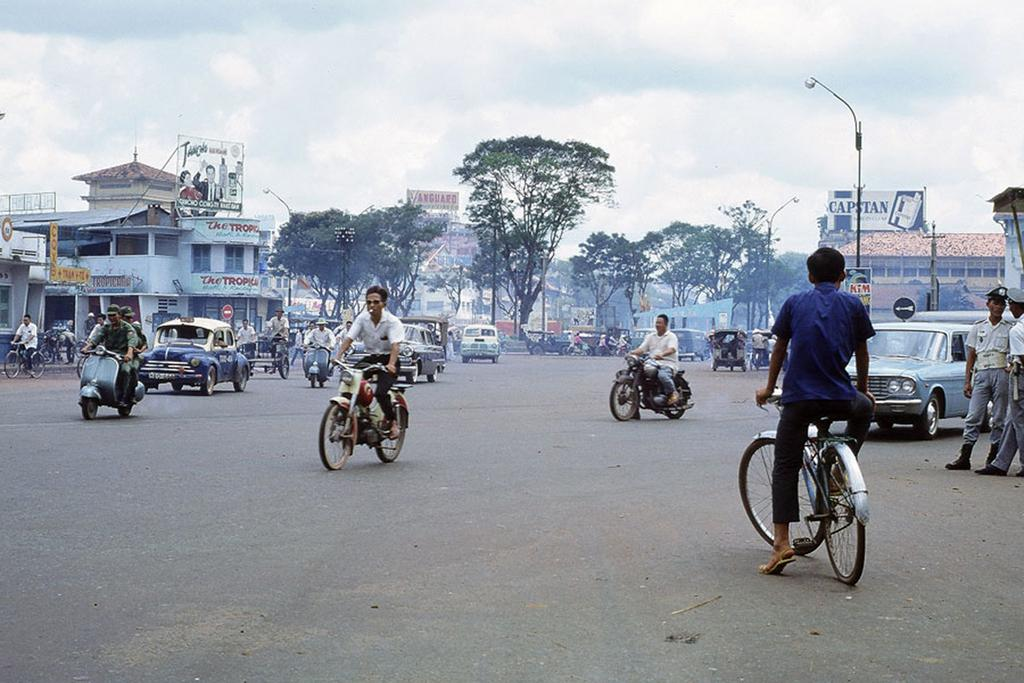What can be seen in the sky in the image? There is a sky in the image, but no specific details are provided about its appearance. What type of vegetation is present in the image? There are trees in the image. What type of structure is visible in the image? There is a building in the image. What is hanging or attached in the image? There is a banner in the image. What type of lighting is present in the image? There is a street lamp in the image. What type of vehicles are on the road in the image? There are cars, motorcycles, and jeeps on the road in the image. What type of toys can be seen playing with the force in the image? There are no toys or any reference to force present in the image. What kind of experience can be gained from the image? The image is a static representation and does not offer any interactive or experiential opportunities. 